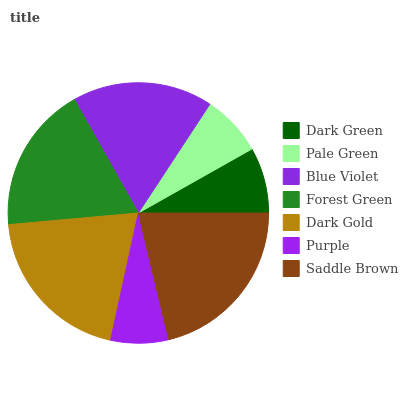Is Purple the minimum?
Answer yes or no. Yes. Is Saddle Brown the maximum?
Answer yes or no. Yes. Is Pale Green the minimum?
Answer yes or no. No. Is Pale Green the maximum?
Answer yes or no. No. Is Dark Green greater than Pale Green?
Answer yes or no. Yes. Is Pale Green less than Dark Green?
Answer yes or no. Yes. Is Pale Green greater than Dark Green?
Answer yes or no. No. Is Dark Green less than Pale Green?
Answer yes or no. No. Is Blue Violet the high median?
Answer yes or no. Yes. Is Blue Violet the low median?
Answer yes or no. Yes. Is Dark Green the high median?
Answer yes or no. No. Is Purple the low median?
Answer yes or no. No. 